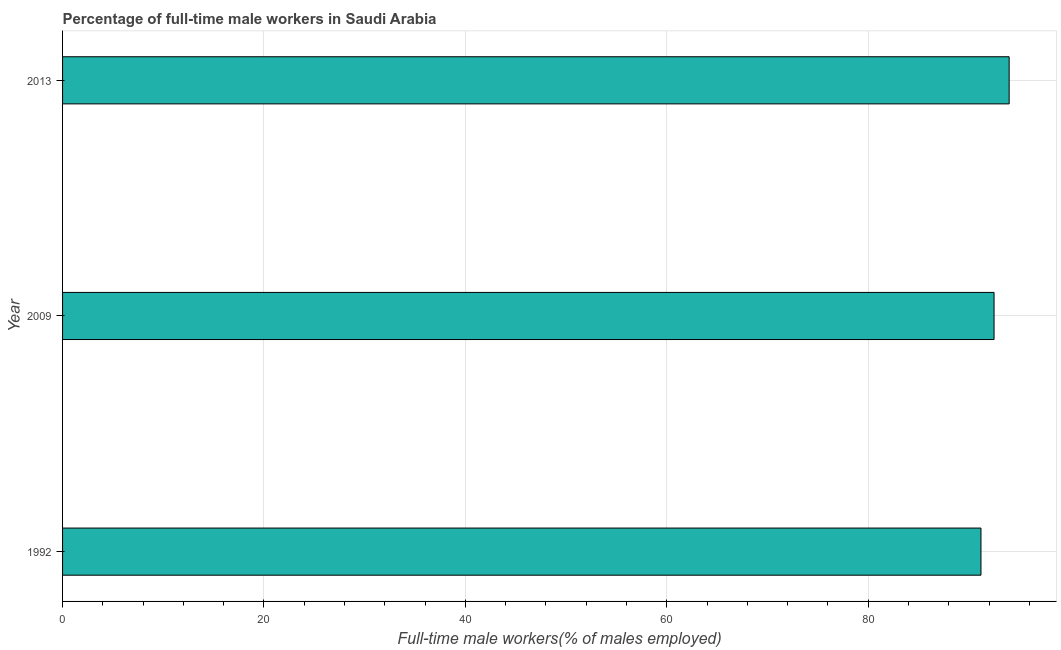Does the graph contain any zero values?
Provide a succinct answer. No. What is the title of the graph?
Give a very brief answer. Percentage of full-time male workers in Saudi Arabia. What is the label or title of the X-axis?
Your answer should be compact. Full-time male workers(% of males employed). What is the percentage of full-time male workers in 2009?
Provide a succinct answer. 92.5. Across all years, what is the maximum percentage of full-time male workers?
Ensure brevity in your answer.  94. Across all years, what is the minimum percentage of full-time male workers?
Offer a very short reply. 91.2. In which year was the percentage of full-time male workers maximum?
Your answer should be compact. 2013. In which year was the percentage of full-time male workers minimum?
Ensure brevity in your answer.  1992. What is the sum of the percentage of full-time male workers?
Offer a very short reply. 277.7. What is the average percentage of full-time male workers per year?
Your answer should be very brief. 92.57. What is the median percentage of full-time male workers?
Provide a succinct answer. 92.5. In how many years, is the percentage of full-time male workers greater than 16 %?
Ensure brevity in your answer.  3. What is the ratio of the percentage of full-time male workers in 2009 to that in 2013?
Ensure brevity in your answer.  0.98. Is the percentage of full-time male workers in 1992 less than that in 2013?
Provide a succinct answer. Yes. Is the difference between the percentage of full-time male workers in 2009 and 2013 greater than the difference between any two years?
Offer a terse response. No. What is the difference between the highest and the lowest percentage of full-time male workers?
Your response must be concise. 2.8. In how many years, is the percentage of full-time male workers greater than the average percentage of full-time male workers taken over all years?
Your response must be concise. 1. How many bars are there?
Provide a short and direct response. 3. Are all the bars in the graph horizontal?
Give a very brief answer. Yes. What is the difference between two consecutive major ticks on the X-axis?
Ensure brevity in your answer.  20. What is the Full-time male workers(% of males employed) in 1992?
Provide a short and direct response. 91.2. What is the Full-time male workers(% of males employed) in 2009?
Give a very brief answer. 92.5. What is the Full-time male workers(% of males employed) in 2013?
Give a very brief answer. 94. What is the difference between the Full-time male workers(% of males employed) in 1992 and 2009?
Give a very brief answer. -1.3. What is the difference between the Full-time male workers(% of males employed) in 2009 and 2013?
Your answer should be very brief. -1.5. What is the ratio of the Full-time male workers(% of males employed) in 1992 to that in 2009?
Your answer should be compact. 0.99. 